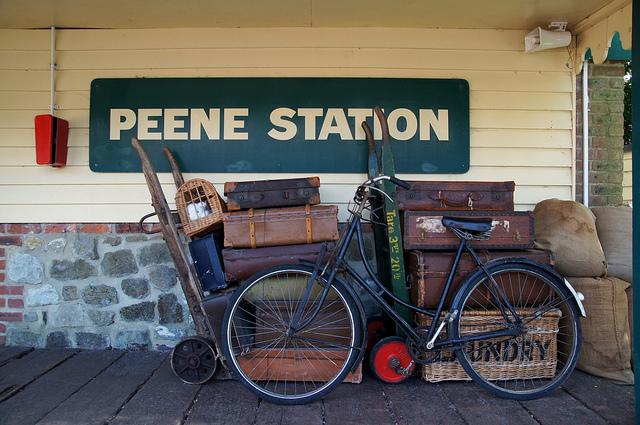Is one or both meters expired?
Keep it brief. No. What color is the bike?
Concise answer only. Blue. What is the title on the sign?
Concise answer only. Penn station. What does the basket say?
Write a very short answer. Laundry. How many bicycles are pictured here?
Give a very brief answer. 1. Is this organized?
Concise answer only. Yes. What are the suitcases stacked on?
Be succinct. Dollies. 